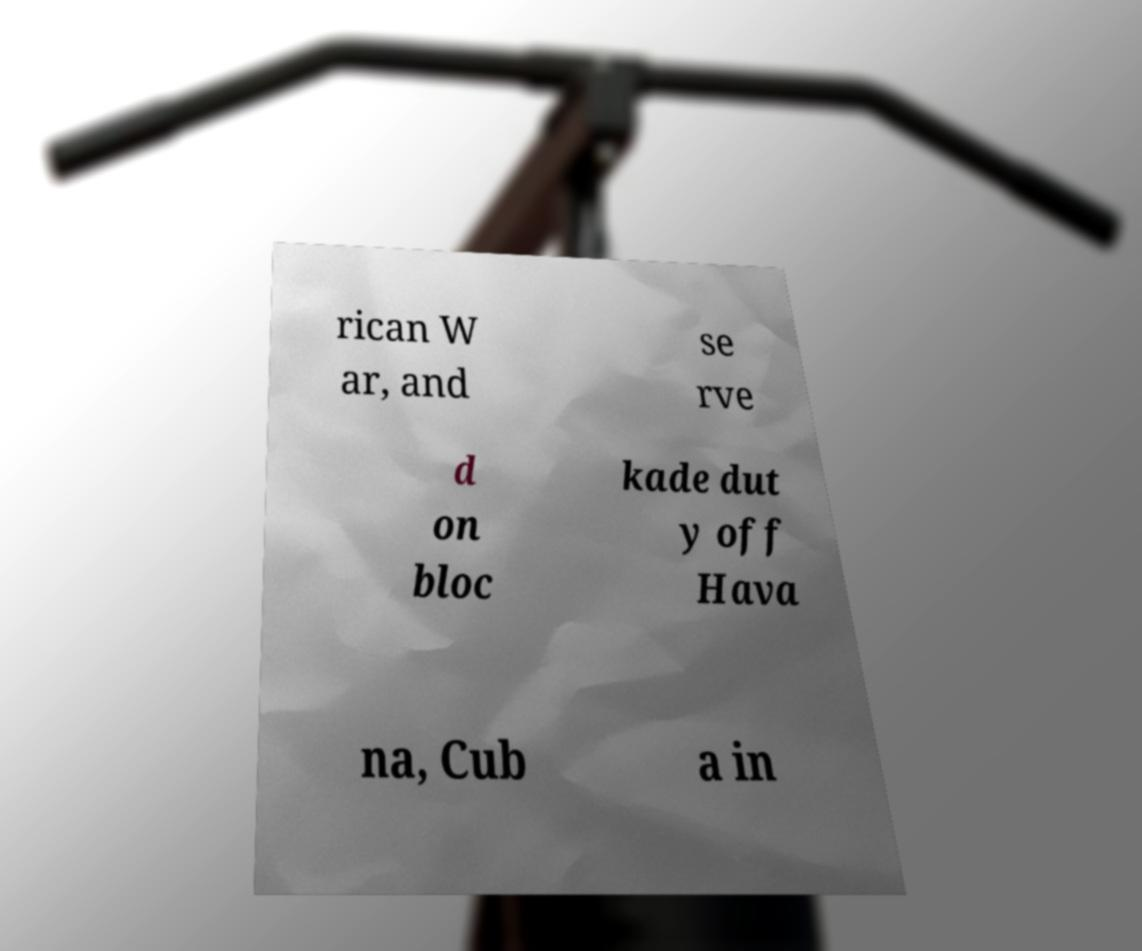There's text embedded in this image that I need extracted. Can you transcribe it verbatim? rican W ar, and se rve d on bloc kade dut y off Hava na, Cub a in 